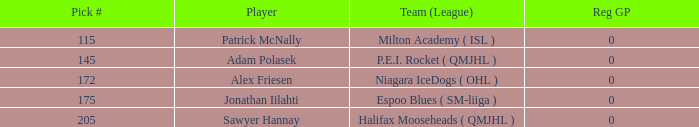What's sawyer hannay's total pick number? 1.0. 